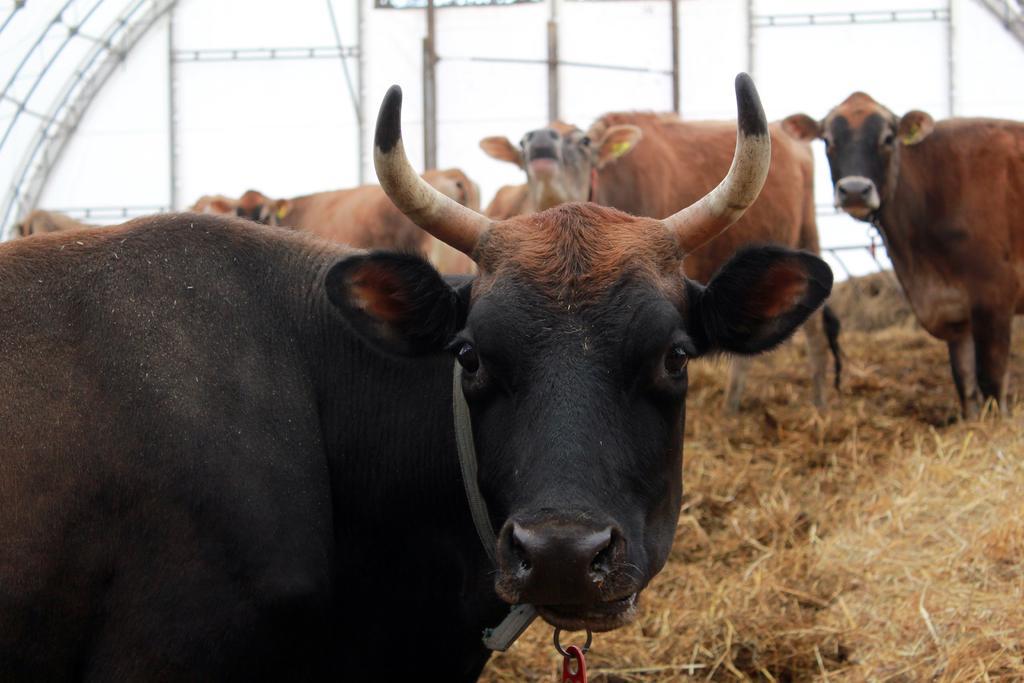Could you give a brief overview of what you see in this image? In the center of the image we can see the cows. In the background of the image we can see a shed. At the bottom of the image we can see the dry grass. 